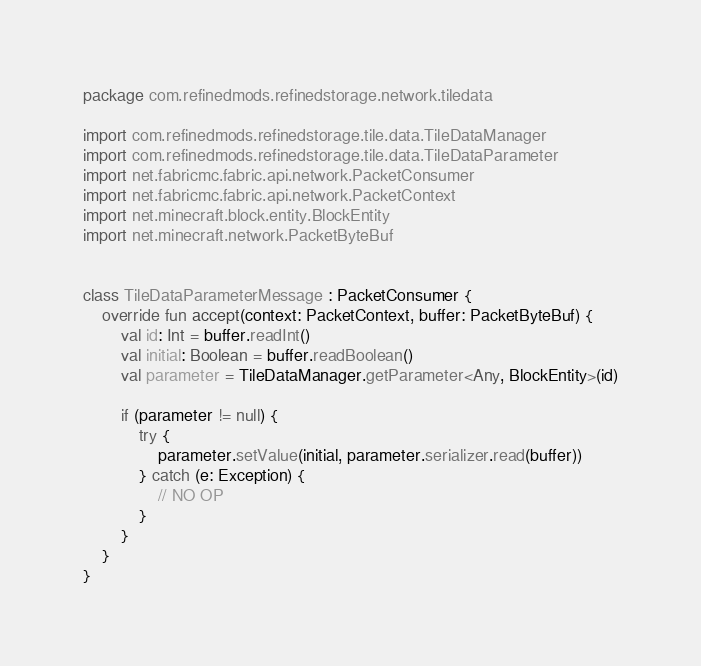Convert code to text. <code><loc_0><loc_0><loc_500><loc_500><_Kotlin_>package com.refinedmods.refinedstorage.network.tiledata

import com.refinedmods.refinedstorage.tile.data.TileDataManager
import com.refinedmods.refinedstorage.tile.data.TileDataParameter
import net.fabricmc.fabric.api.network.PacketConsumer
import net.fabricmc.fabric.api.network.PacketContext
import net.minecraft.block.entity.BlockEntity
import net.minecraft.network.PacketByteBuf


class TileDataParameterMessage : PacketConsumer {
    override fun accept(context: PacketContext, buffer: PacketByteBuf) {
        val id: Int = buffer.readInt()
        val initial: Boolean = buffer.readBoolean()
        val parameter = TileDataManager.getParameter<Any, BlockEntity>(id)

        if (parameter != null) {
            try {
                parameter.setValue(initial, parameter.serializer.read(buffer))
            } catch (e: Exception) {
                // NO OP
            }
        }
    }
}
</code> 